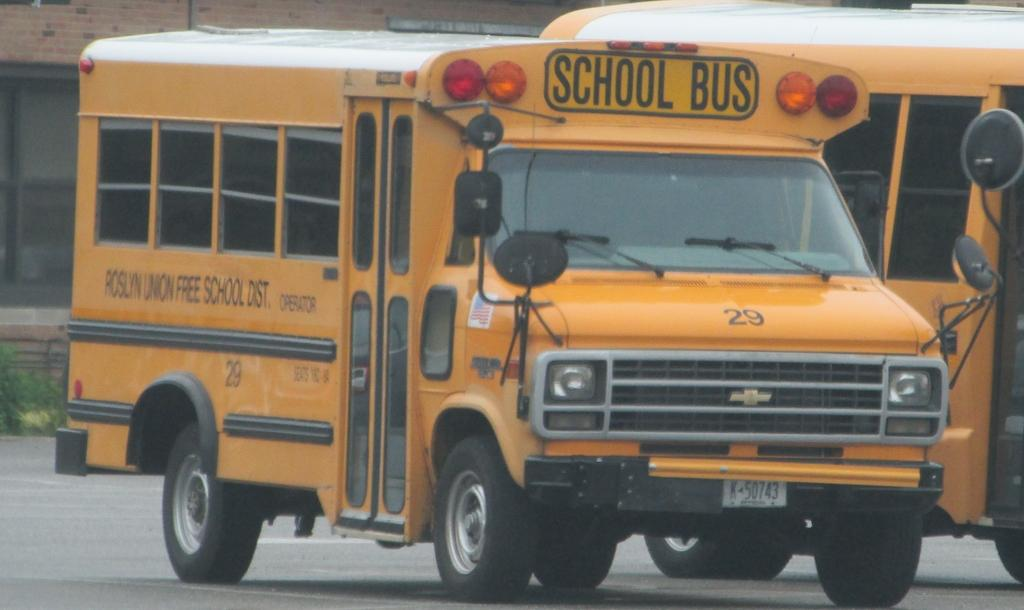Provide a one-sentence caption for the provided image. A school bus with "Roslyn Union Free School Dist." written on the side of it. 